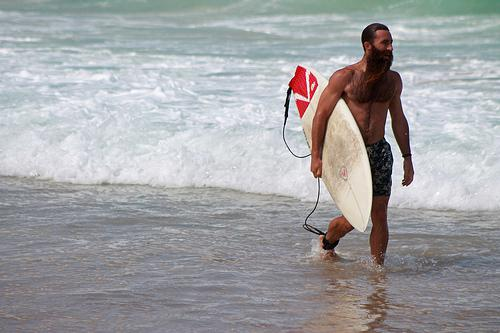Question: why is he wet?
Choices:
A. From a water balloon fight.
B. From a water gun fight.
C. From swimming.
D. From water.
Answer with the letter. Answer: D Question: where is he?
Choices:
A. On the sand.
B. Beachside.
C. Near the ocean.
D. At the beach.
Answer with the letter. Answer: B Question: who is there?
Choices:
A. Woman.
B. Child.
C. Man.
D. Senior citizen.
Answer with the letter. Answer: C Question: what is he carrying?
Choices:
A. Surfboard.
B. Boogie board.
C. Longboard.
D. Body board.
Answer with the letter. Answer: A 